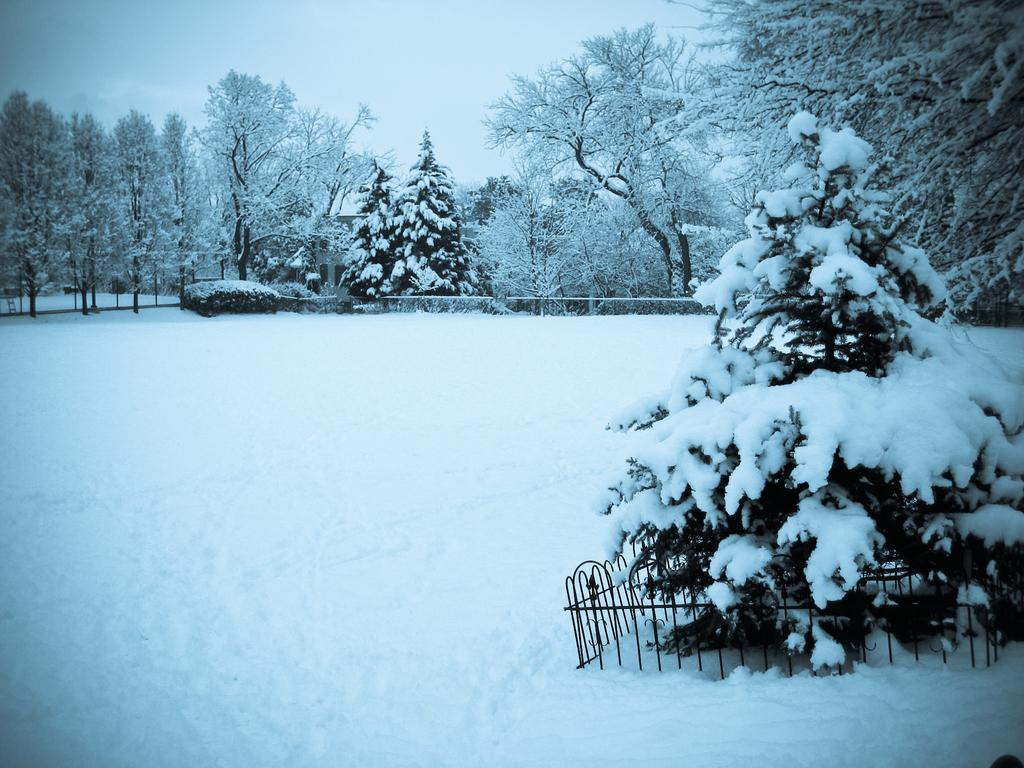What type of vegetation is covered by snow in the image? There are trees covered by snow in the image. What is present at the bottom of the image? There is snow at the bottom of the image. What type of architectural feature can be seen in the image? There are grilles visible in the image. What can be seen in the background of the image? The sky is visible in the background of the image. What type of stick can be seen in the jar in the image? There is no stick or jar present in the image; it features snow-covered trees, snow at the bottom, grilles, and a visible sky in the background. 